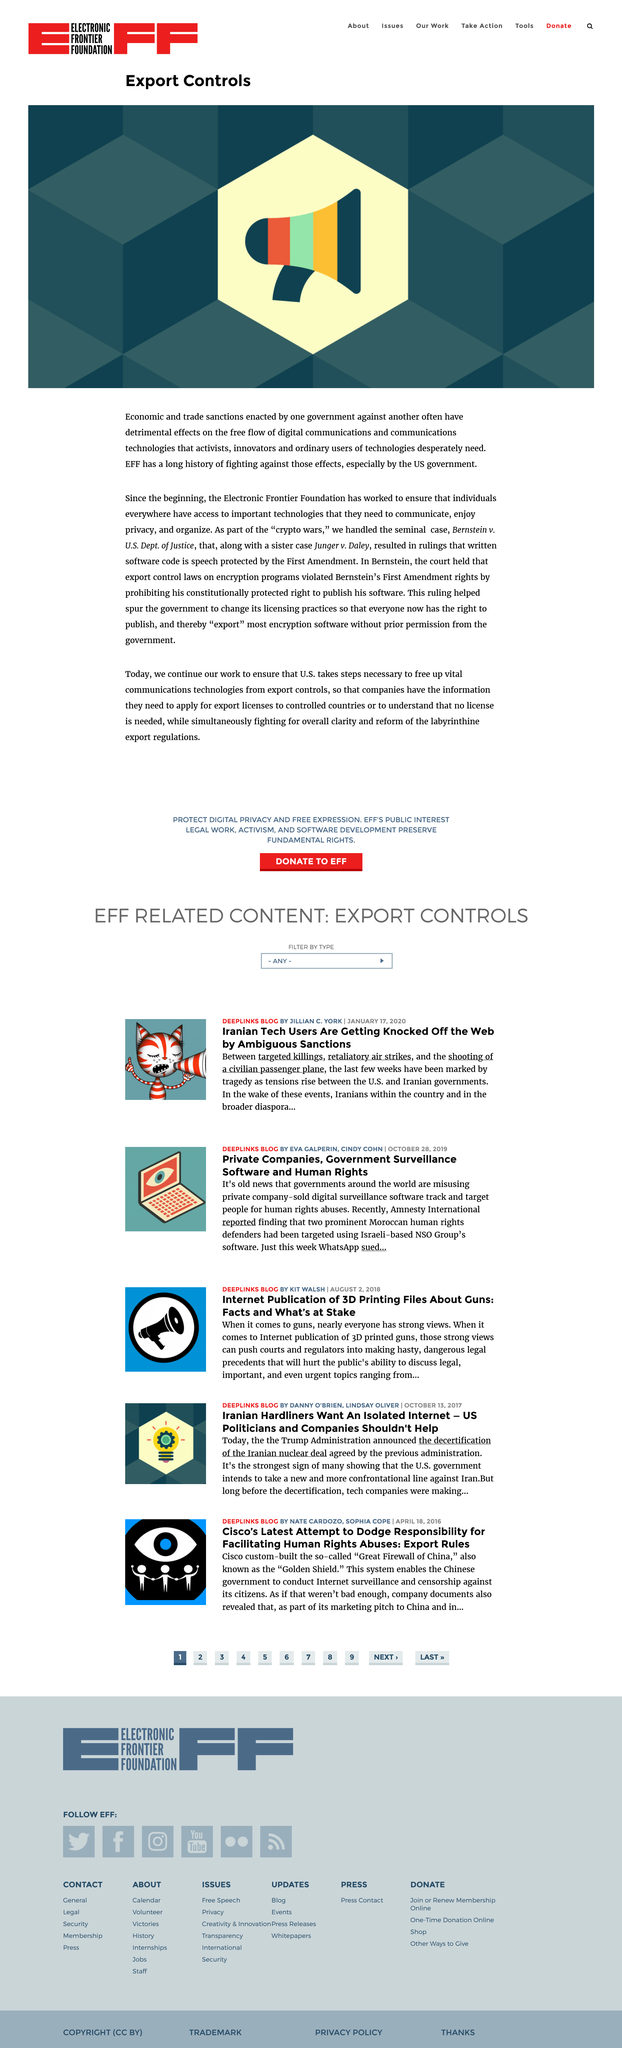Point out several critical features in this image. The Bernstein v U.S. Dept. of Justice case was the seminal legal case that the Electronic Frontier Foundation (EFF) handled. The written software code is a form of speech that is protected by the First Amendment to the United States Constitution. The acronym "EFF" stands for the Electronic Frontier Foundation, which is a non-profit organization that advocates for the protection of civil liberties in the digital world. 